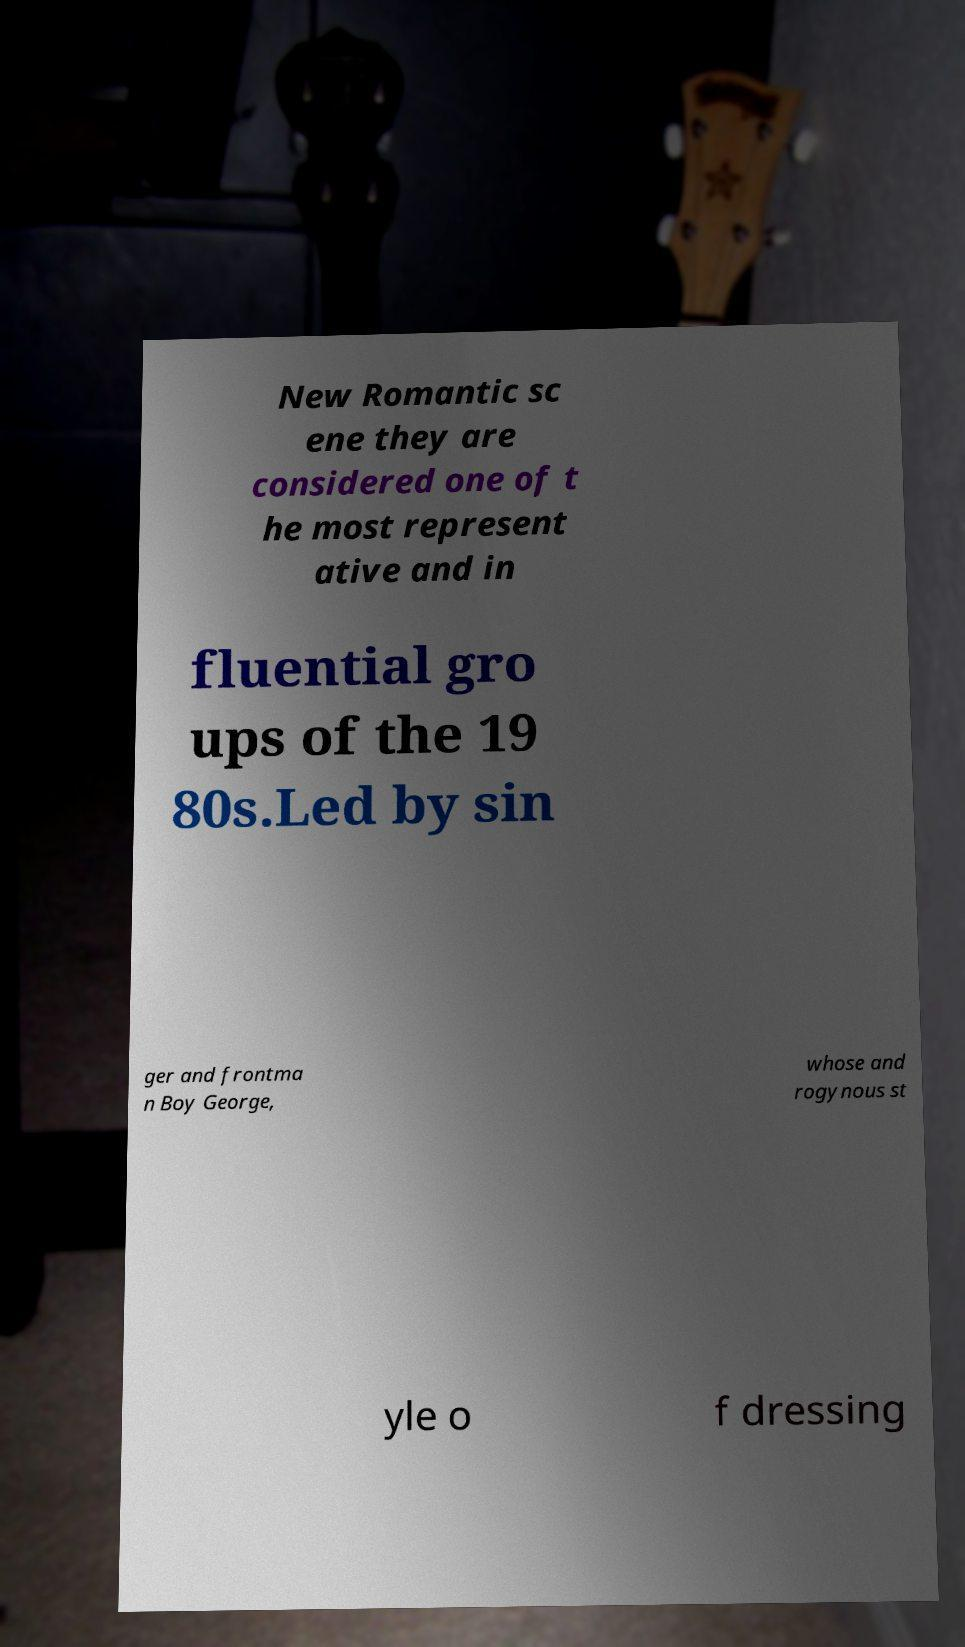For documentation purposes, I need the text within this image transcribed. Could you provide that? New Romantic sc ene they are considered one of t he most represent ative and in fluential gro ups of the 19 80s.Led by sin ger and frontma n Boy George, whose and rogynous st yle o f dressing 